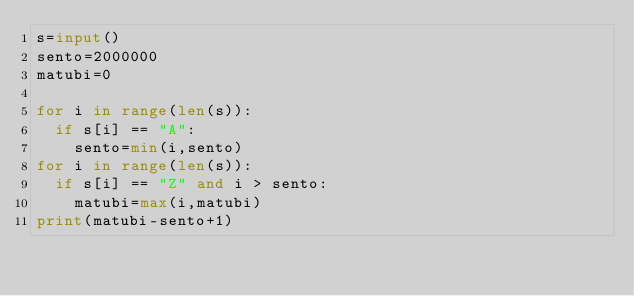<code> <loc_0><loc_0><loc_500><loc_500><_Python_>s=input()
sento=2000000
matubi=0

for i in range(len(s)):
  if s[i] == "A":
    sento=min(i,sento)
for i in range(len(s)):
  if s[i] == "Z" and i > sento:
    matubi=max(i,matubi)
print(matubi-sento+1)</code> 